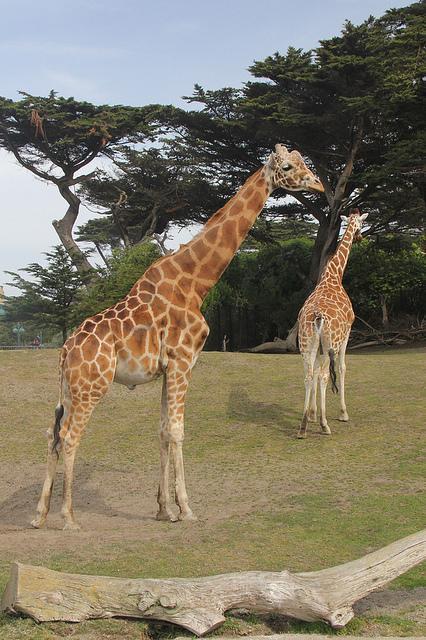How many animals are here?
Give a very brief answer. 2. How many giraffes are there?
Give a very brief answer. 2. 